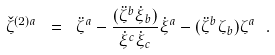<formula> <loc_0><loc_0><loc_500><loc_500>\check { \zeta } ^ { ( 2 ) a } \ = \ \ddot { \zeta } ^ { a } - \frac { ( \ddot { \zeta } ^ { b } \dot { \xi } _ { b } ) } { \dot { \xi } ^ { c } \dot { \xi } _ { c } } \dot { \xi } ^ { a } - ( \ddot { \zeta } ^ { b } \zeta _ { b } ) \zeta ^ { a } \ .</formula> 